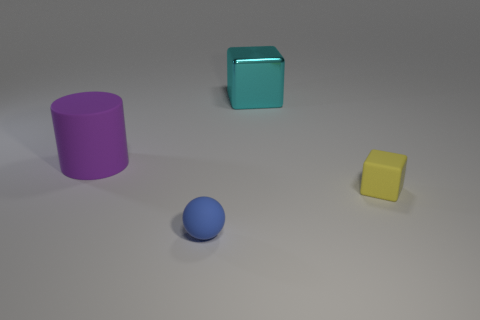Is there anything else that is made of the same material as the large cyan object?
Provide a short and direct response. No. Are there any other things that have the same shape as the blue matte thing?
Provide a short and direct response. No. There is a large cyan object that is the same shape as the yellow thing; what is its material?
Your answer should be very brief. Metal. There is a small matte object that is to the right of the tiny blue rubber thing; is it the same shape as the big metal thing?
Make the answer very short. Yes. Is there any other thing that has the same size as the purple matte cylinder?
Give a very brief answer. Yes. Is the number of small things that are left of the purple cylinder less than the number of large cyan cubes that are in front of the large cyan object?
Provide a succinct answer. No. How many other things are there of the same shape as the big rubber object?
Provide a short and direct response. 0. There is a matte thing that is to the left of the tiny thing that is in front of the block in front of the metal cube; what size is it?
Give a very brief answer. Large. What number of cyan things are either balls or big metallic cubes?
Provide a succinct answer. 1. What shape is the large thing to the right of the large object that is on the left side of the blue matte thing?
Provide a succinct answer. Cube. 